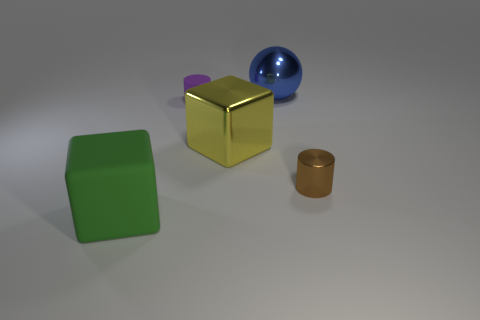The big object that is right of the tiny purple cylinder and in front of the purple matte thing is what color?
Make the answer very short. Yellow. There is a metal ball behind the rubber cylinder; is its size the same as the tiny shiny cylinder?
Make the answer very short. No. There is a large cube on the right side of the large green thing; are there any yellow cubes that are left of it?
Offer a very short reply. No. What is the large blue thing made of?
Keep it short and to the point. Metal. There is a big blue metallic object; are there any yellow shiny cubes behind it?
Keep it short and to the point. No. What size is the brown thing that is the same shape as the purple matte thing?
Provide a short and direct response. Small. Are there the same number of brown metallic cylinders left of the matte cube and rubber cylinders that are to the left of the small purple cylinder?
Offer a very short reply. Yes. How many big green matte things are there?
Give a very brief answer. 1. Is the number of rubber cubes that are behind the brown cylinder greater than the number of blue metal cubes?
Provide a short and direct response. No. There is a tiny cylinder to the left of the brown thing; what is its material?
Your answer should be compact. Rubber. 